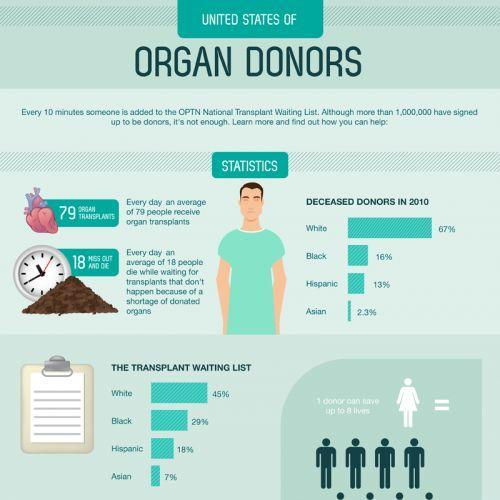What is total percentage of donors deceased in 2010 in the categories White, Black, Hispanci and Asian?
Answer the question with a short phrase. 98.3% Give the percentage difference between White and Asian deceased donors? 64.7% Give the total percentage of transplant waiting list for Hispanic and Black? 47% Which has a lower percentage of deceased donors in 2010 White, Hispanic or Black? Hispanic Which has a higher percentage of transplant waiting list Asian, Black or Hispanic? Black What is the total percentage of people in the transplant waiting list? 99% 